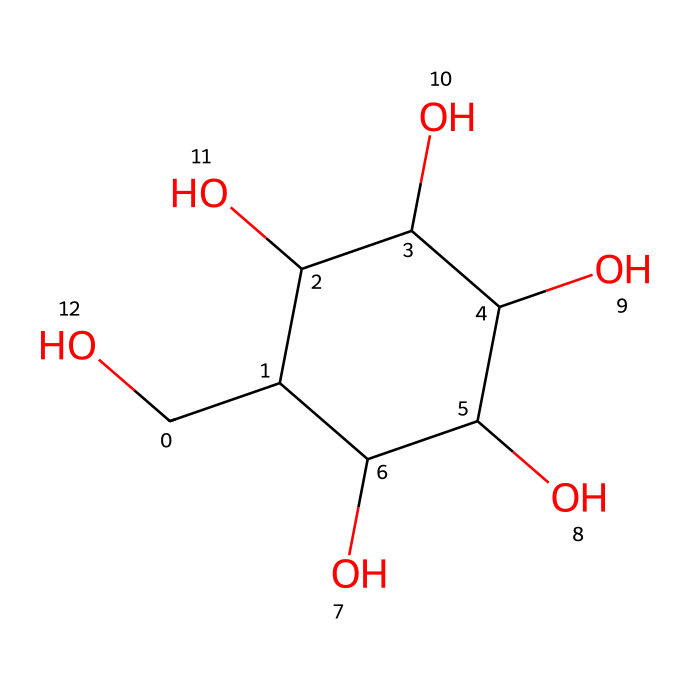What is the total number of carbon atoms in oobleck? Upon examining the chemical structure, we can see that there are six carbon atoms directly indicated in the structure. Counting each carbon (C) gives us a total of 6.
Answer: 6 How many hydroxyl (OH) groups are present in this molecule? Looking at the structure, we identify that there are five hydroxyl (OH) groups attached to the carbon atoms in the molecule. Each OH group can be seen branching off from the carbons.
Answer: 5 What type of structural isomer is oobleck? The structure indicates that oobleck, primarily made of cornstarch, can be classified as a polysaccharide, which is characterized by repeating monosaccharide units.
Answer: polysaccharide How does the structure contribute to oobleck behaving as a Non-Newtonian fluid? The presence of multiple hydroxyl groups significantly increases its hydrogen bonding capabilities, leading to changes in viscosity under stress, which is a characteristic of Non-Newtonian fluids.
Answer: hydrogen bonding What is the molecular formula derived from the SMILES representation? From the given SMILES, we can count the elements to conclude that the molecular formula is C6H14O5, as it contains 6 carbon (C), 14 hydrogen (H), and 5 oxygen (O) atoms.
Answer: C6H14O5 What feature in the structure indicates that it is a carbohydrate? The multiple -OH (hydroxyl) groups throughout the structure are characteristic of carbohydrates, confirming its classification as such, due to their high degree of hydration and polar characteristics.
Answer: -OH groups 